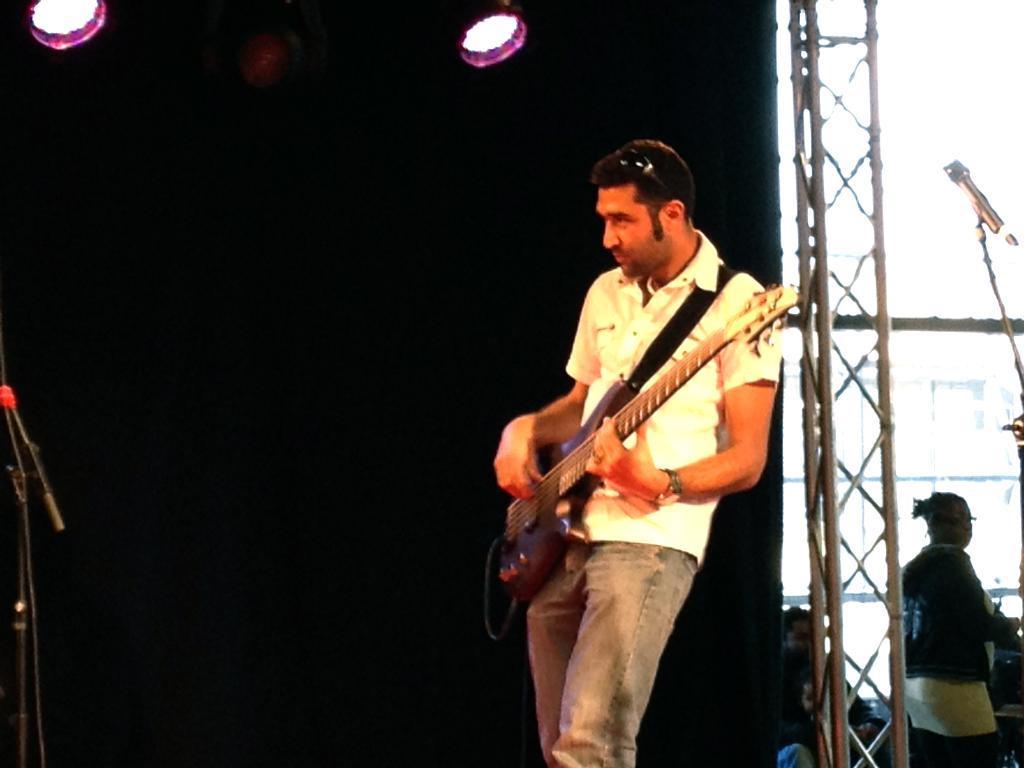Could you give a brief overview of what you see in this image? There is a man and he is playing guitar. Here we can see lights and this is mike. And there is a person. 